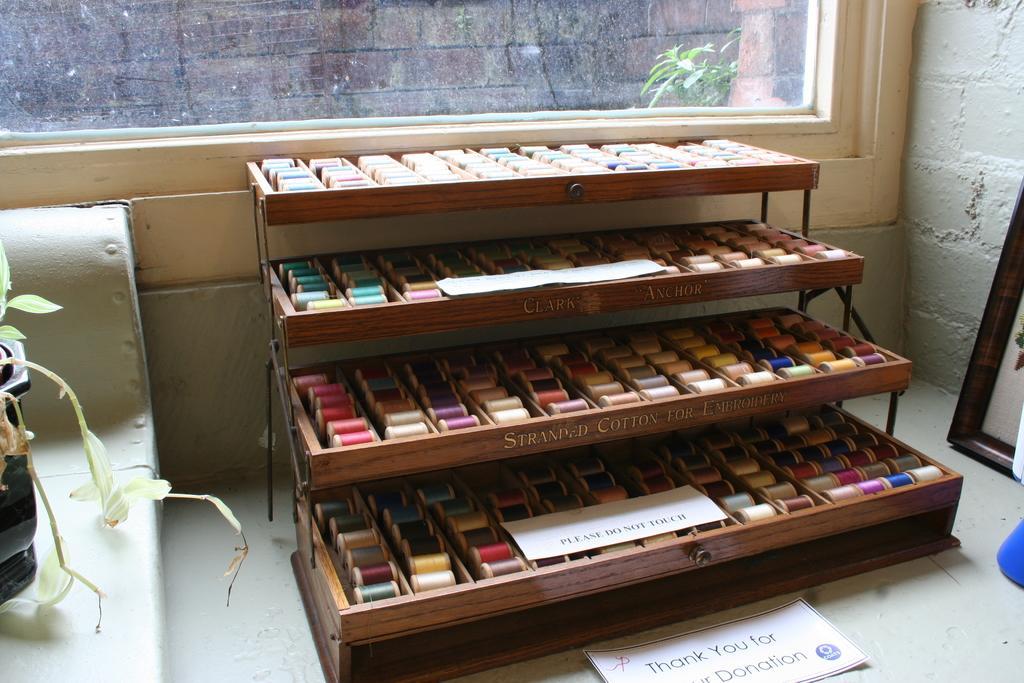Could you give a brief overview of what you see in this image? In this image there is a pot on the left side. There is a step by step table. There are many threads bundles. There is a wall on the right side. There is a wall with glass in the background. There is a plant behind the glass. There is a wall behind the glass. 